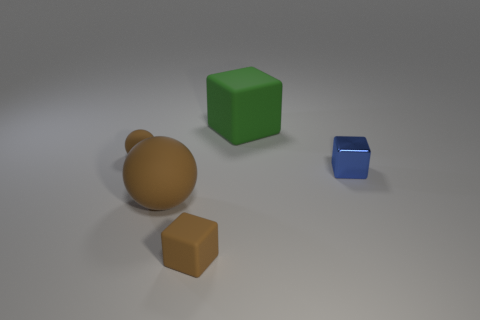What size is the cube that is the same color as the big sphere?
Give a very brief answer. Small. There is a rubber block right of the brown rubber block; are there any metal cubes to the left of it?
Make the answer very short. No. How many things are either large things behind the blue shiny cube or matte objects in front of the blue metal object?
Keep it short and to the point. 3. Is there any other thing of the same color as the small ball?
Ensure brevity in your answer.  Yes. What color is the cube that is on the right side of the matte block that is behind the small brown thing behind the big brown rubber thing?
Ensure brevity in your answer.  Blue. There is a block that is in front of the large brown matte ball that is left of the large cube; what size is it?
Offer a very short reply. Small. There is a tiny object that is behind the large brown rubber ball and on the right side of the big brown rubber sphere; what material is it made of?
Your answer should be compact. Metal. There is a green matte block; is it the same size as the rubber cube in front of the big matte sphere?
Offer a very short reply. No. Are there any blocks?
Your answer should be compact. Yes. There is a brown thing that is the same shape as the blue object; what material is it?
Your answer should be compact. Rubber. 